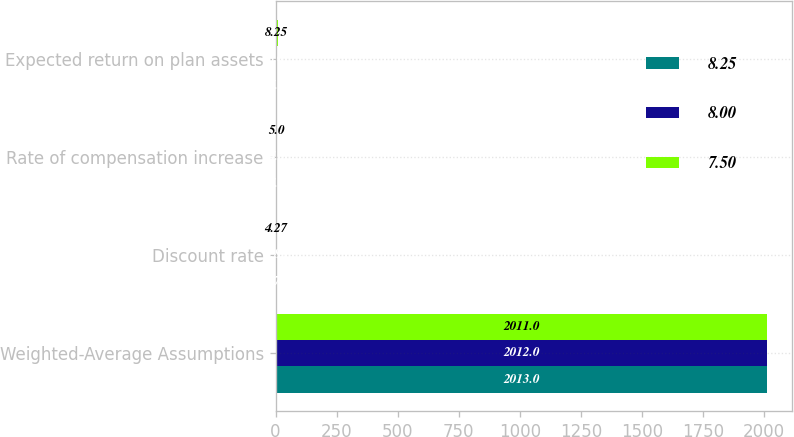Convert chart. <chart><loc_0><loc_0><loc_500><loc_500><stacked_bar_chart><ecel><fcel>Weighted-Average Assumptions<fcel>Discount rate<fcel>Rate of compensation increase<fcel>Expected return on plan assets<nl><fcel>8.25<fcel>2013<fcel>4.72<fcel>4<fcel>7.5<nl><fcel>8<fcel>2012<fcel>3.83<fcel>4<fcel>8<nl><fcel>7.5<fcel>2011<fcel>4.27<fcel>5<fcel>8.25<nl></chart> 